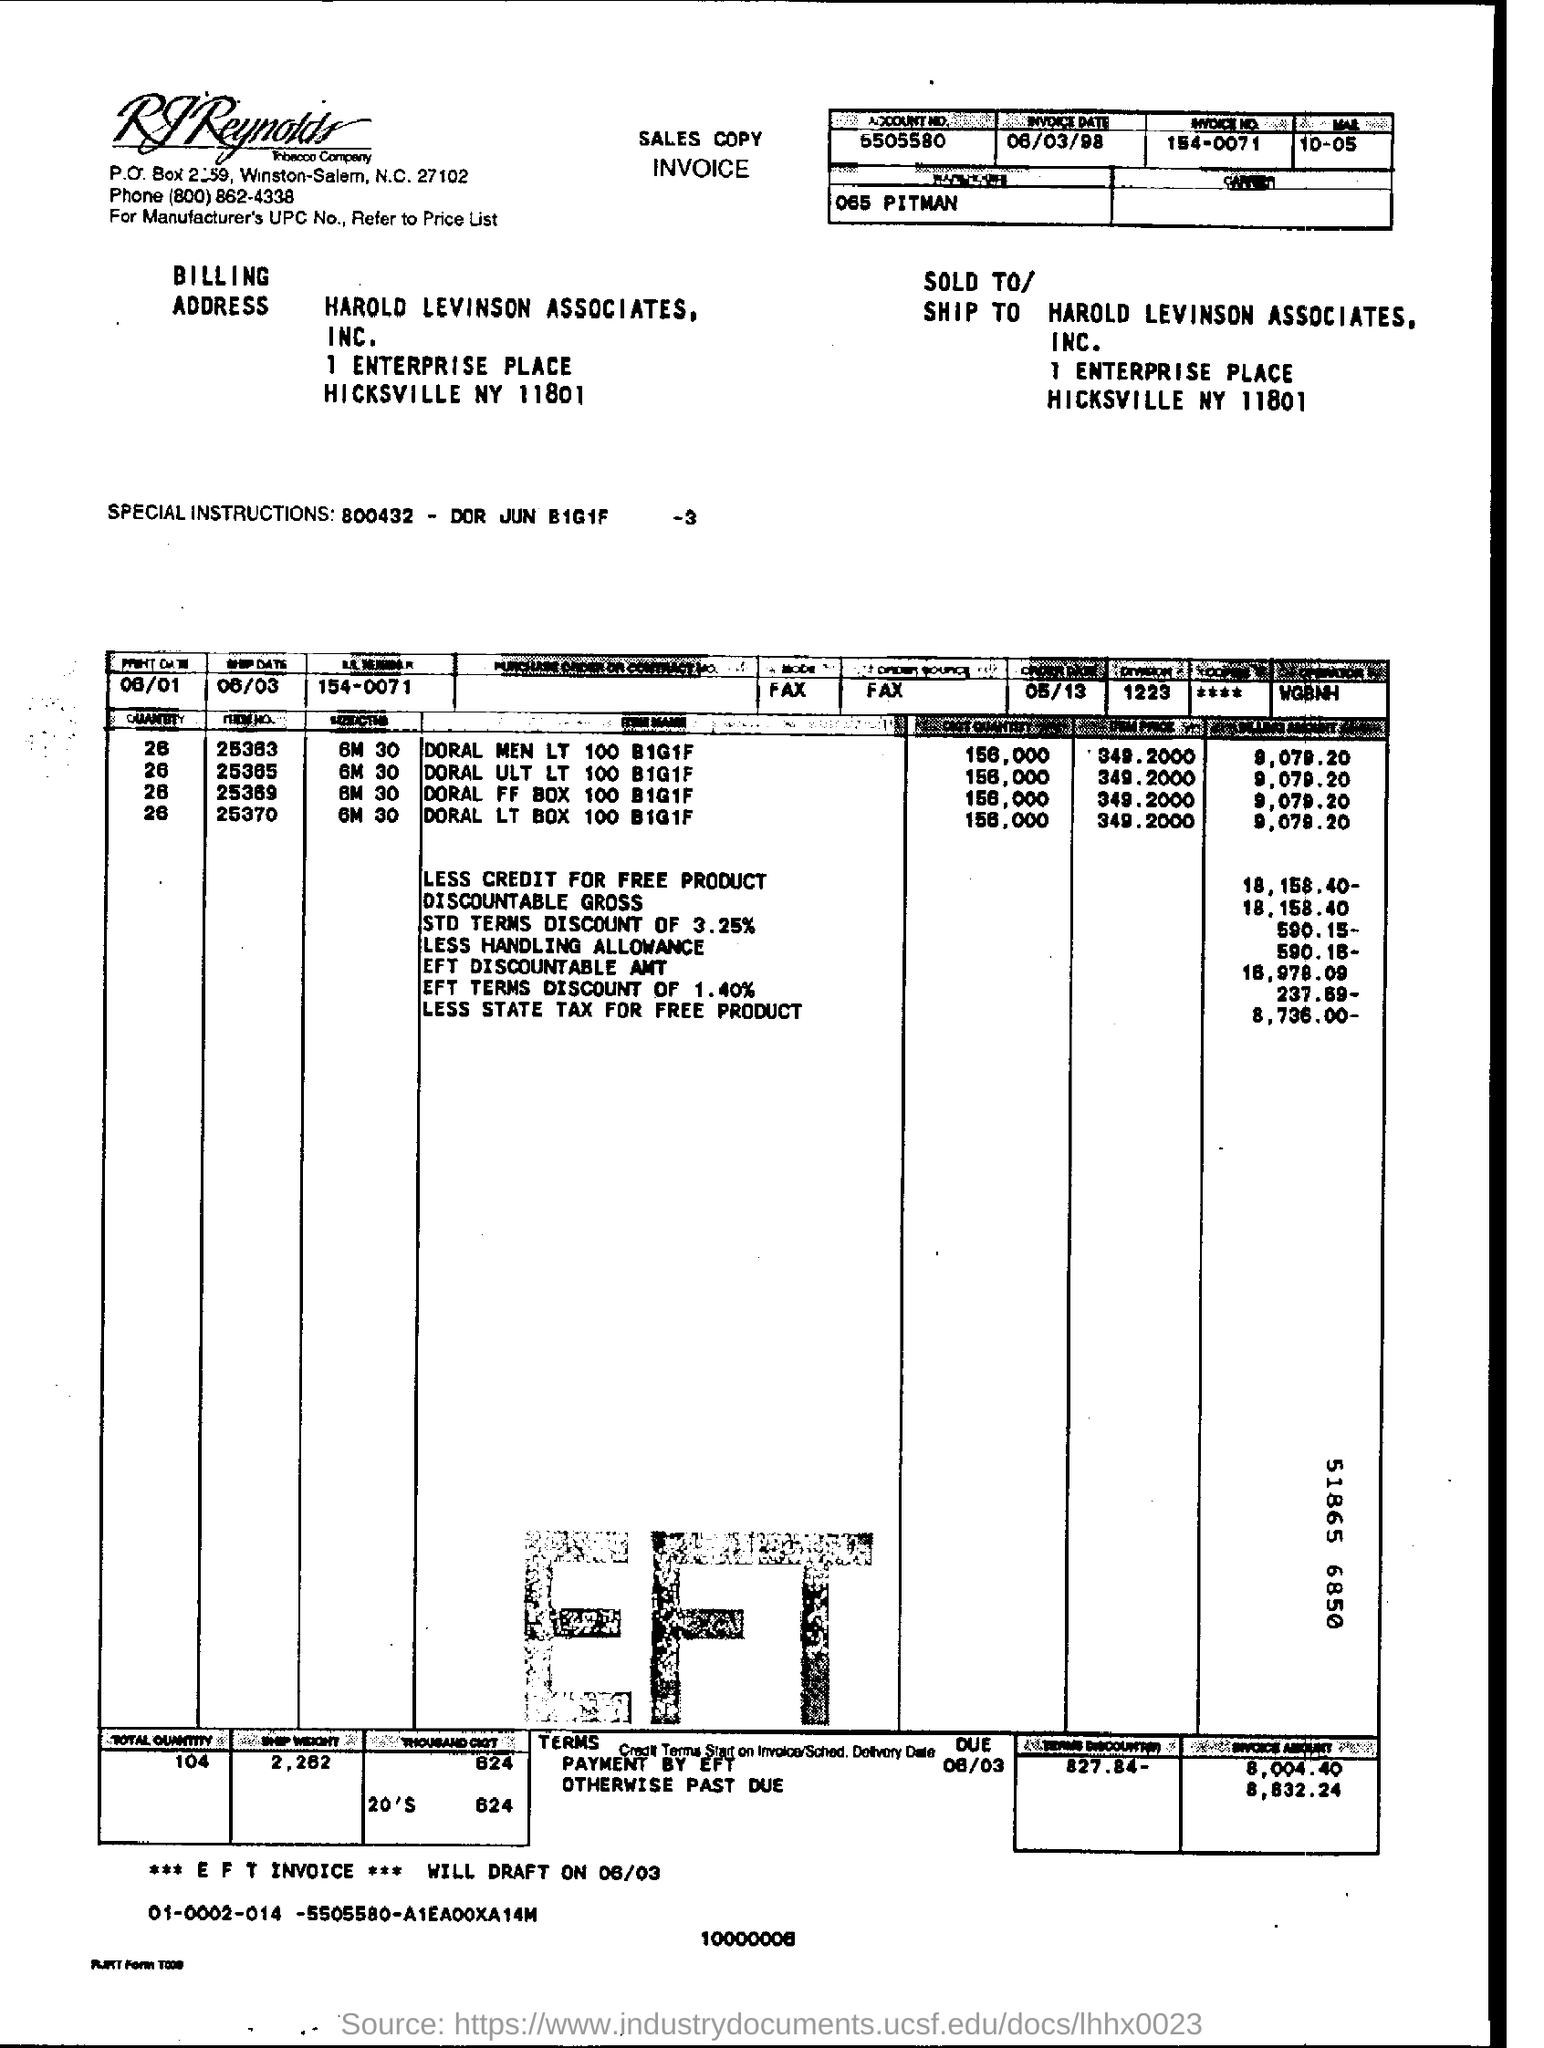what is the ***EFT INVOICE *** WILL DRAFT ON ? The EFT (Electronic Funds Transfer) invoice is scheduled to draft on June 3rd, as indicated by the terms section at the bottom right of the invoice image. 